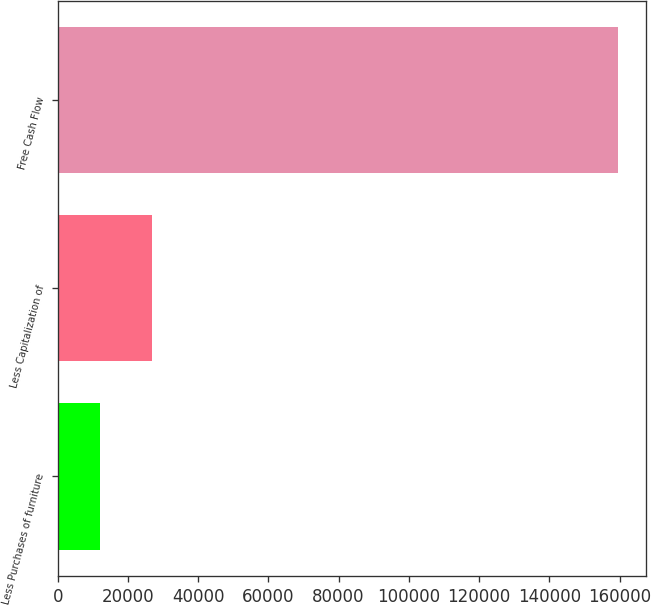Convert chart to OTSL. <chart><loc_0><loc_0><loc_500><loc_500><bar_chart><fcel>Less Purchases of furniture<fcel>Less Capitalization of<fcel>Free Cash Flow<nl><fcel>12086<fcel>26833.3<fcel>159559<nl></chart> 